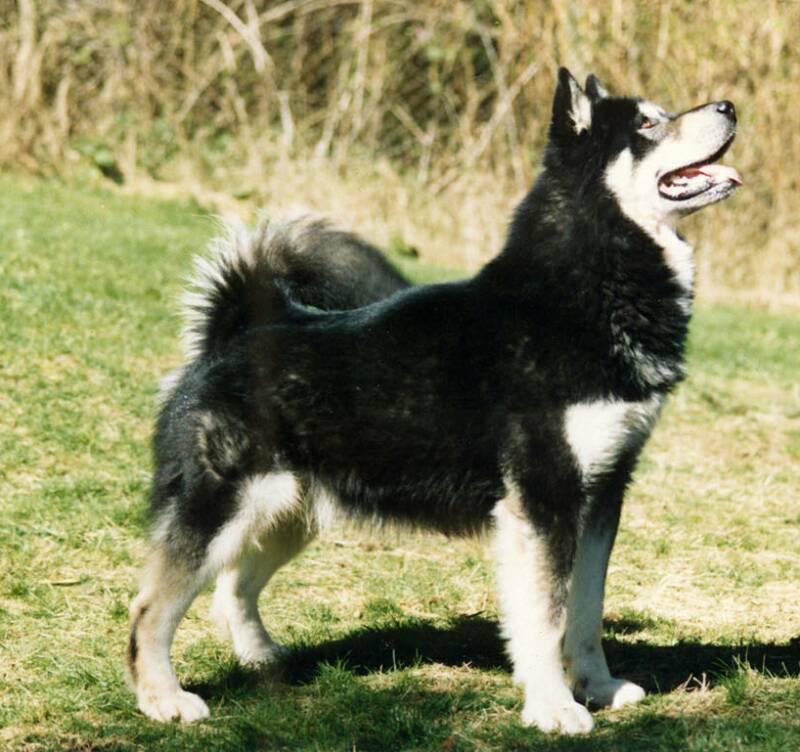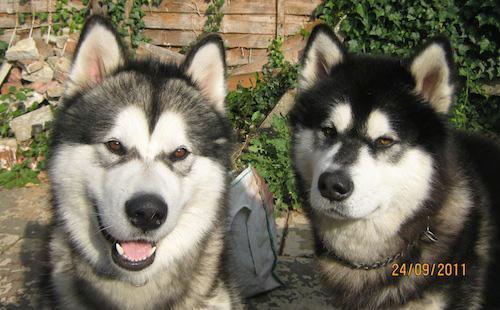The first image is the image on the left, the second image is the image on the right. For the images shown, is this caption "a husky is standing in the grass" true? Answer yes or no. Yes. The first image is the image on the left, the second image is the image on the right. Considering the images on both sides, is "The dog in one of the images is standing in the grass." valid? Answer yes or no. Yes. 